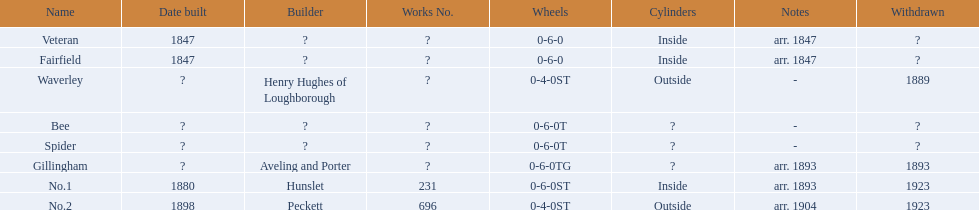What are the aldernay railways? Veteran, Fairfield, Waverley, Bee, Spider, Gillingham, No.1, No.2. Which ones were built in 1847? Veteran, Fairfield. Of those, which one is not fairfield? Veteran. 